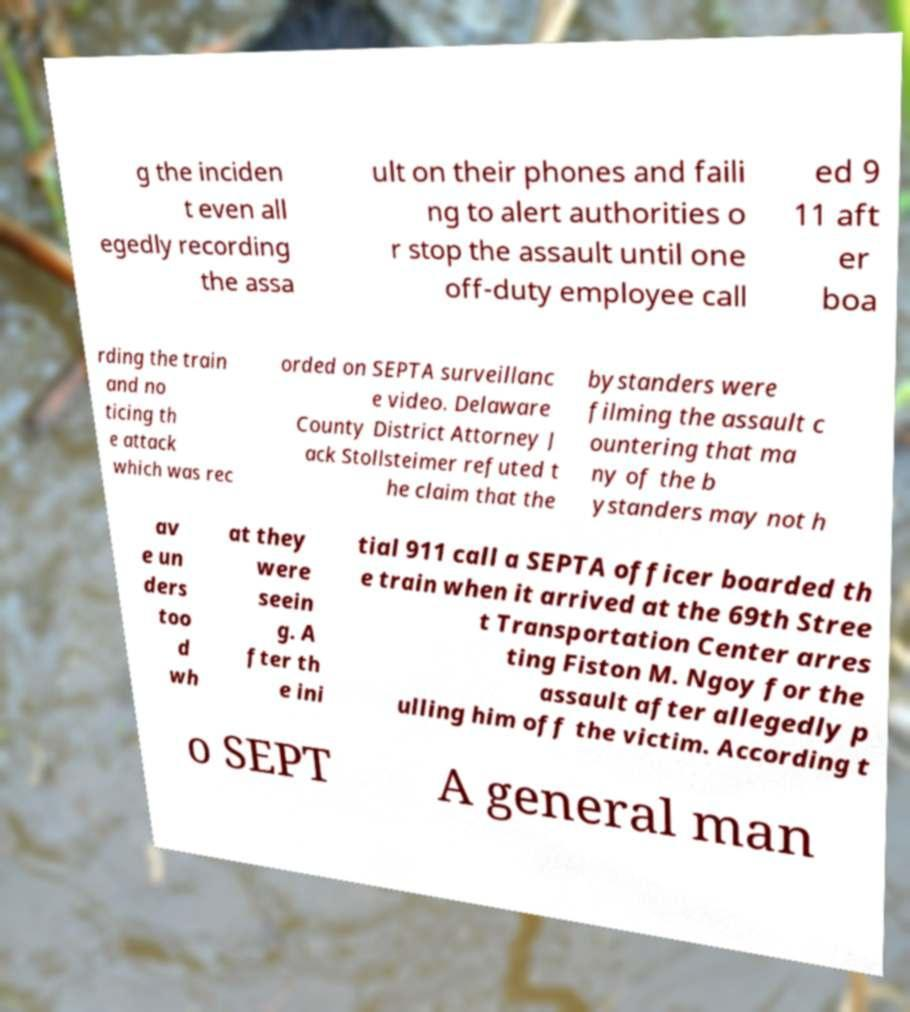Could you extract and type out the text from this image? g the inciden t even all egedly recording the assa ult on their phones and faili ng to alert authorities o r stop the assault until one off-duty employee call ed 9 11 aft er boa rding the train and no ticing th e attack which was rec orded on SEPTA surveillanc e video. Delaware County District Attorney J ack Stollsteimer refuted t he claim that the bystanders were filming the assault c ountering that ma ny of the b ystanders may not h av e un ders too d wh at they were seein g. A fter th e ini tial 911 call a SEPTA officer boarded th e train when it arrived at the 69th Stree t Transportation Center arres ting Fiston M. Ngoy for the assault after allegedly p ulling him off the victim. According t o SEPT A general man 